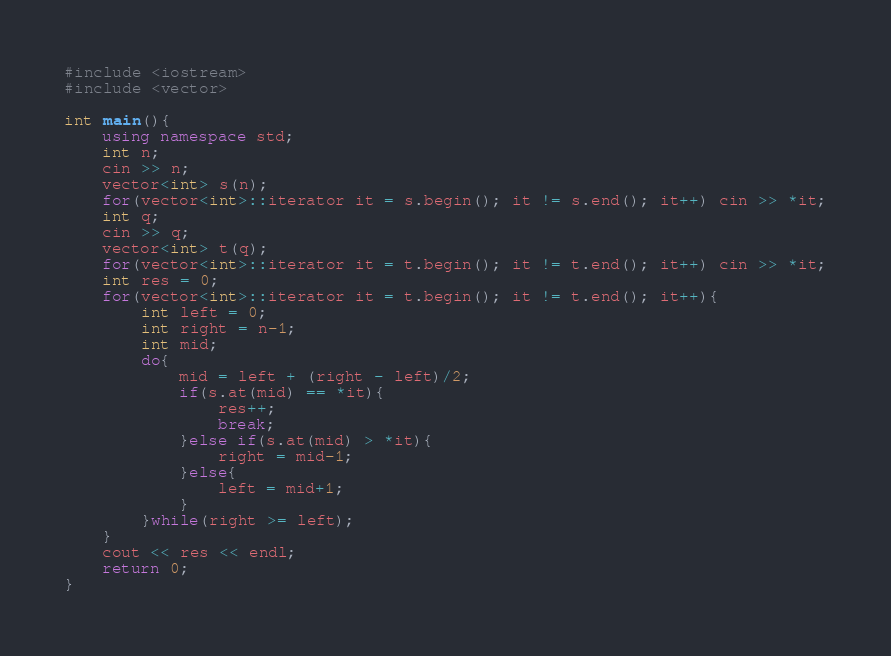Convert code to text. <code><loc_0><loc_0><loc_500><loc_500><_C++_>#include <iostream>
#include <vector>

int main(){
    using namespace std;
    int n;
    cin >> n;
    vector<int> s(n);
    for(vector<int>::iterator it = s.begin(); it != s.end(); it++) cin >> *it;
    int q;
    cin >> q;
    vector<int> t(q);
    for(vector<int>::iterator it = t.begin(); it != t.end(); it++) cin >> *it;
    int res = 0;
    for(vector<int>::iterator it = t.begin(); it != t.end(); it++){
        int left = 0;
        int right = n-1;
        int mid;
        do{
            mid = left + (right - left)/2;
            if(s.at(mid) == *it){
                res++;
                break;
            }else if(s.at(mid) > *it){
                right = mid-1;
            }else{
                left = mid+1;
            }
        }while(right >= left);
    }
    cout << res << endl;
    return 0;
}
</code> 